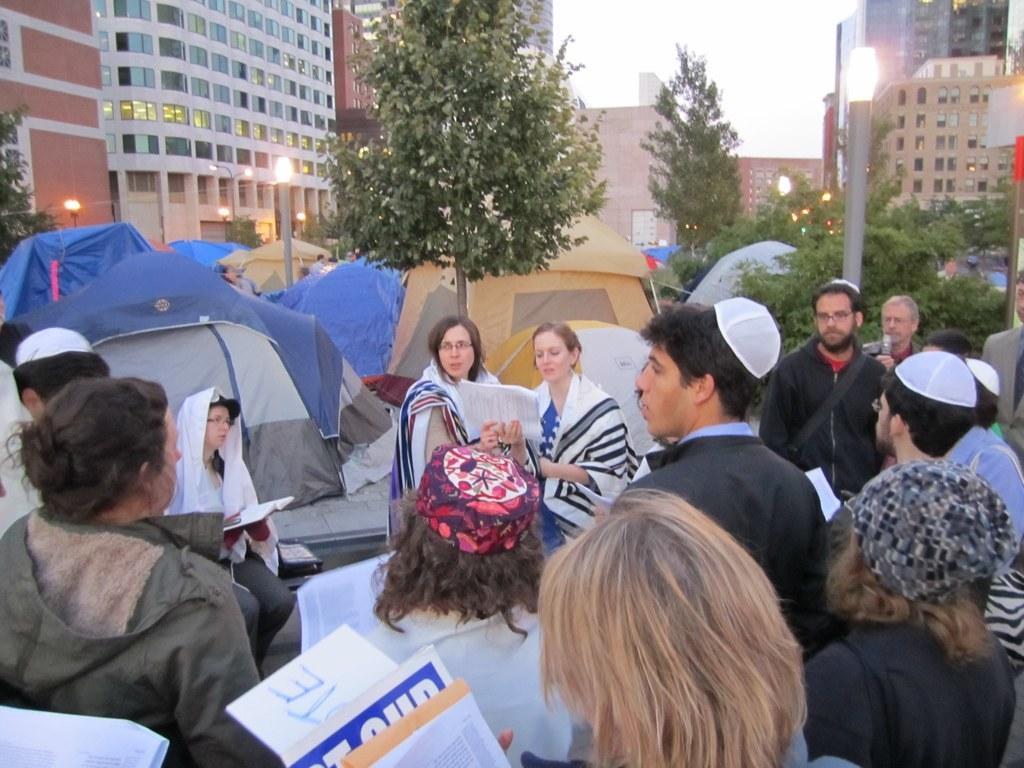In one or two sentences, can you explain what this image depicts? In this image there are a group of people who are holding papers, and some of them reading and one person is holding a mike. On the right side and in the background there are tents, trees, poles, lights and buildings. At the top there is sky. 